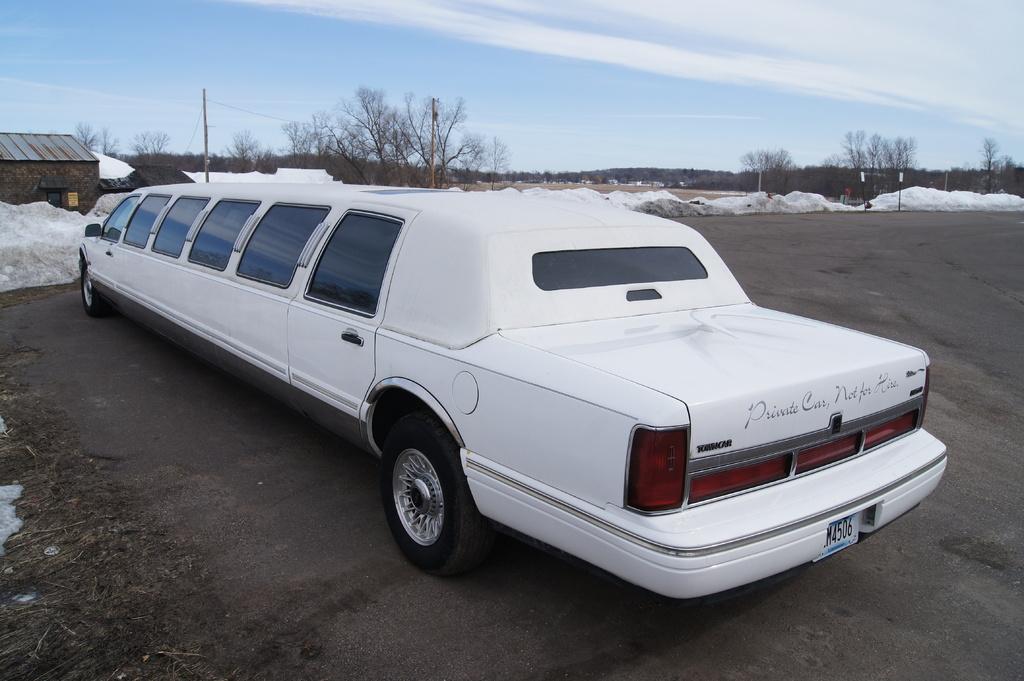Could you give a brief overview of what you see in this image? In this image we can see white color limousine car which is on road and in the background of the image there is house, snow, there are some trees and clear sky. 